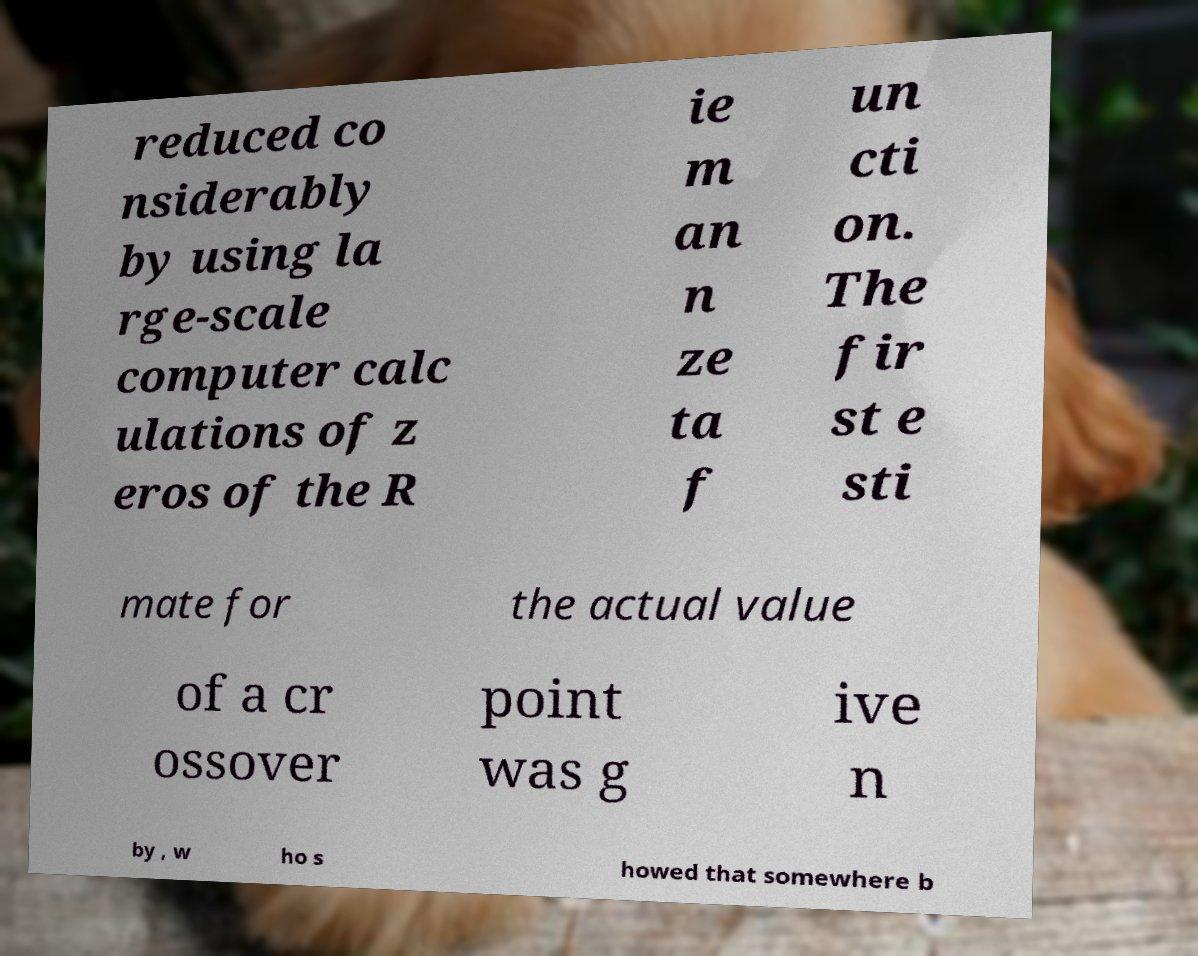Could you assist in decoding the text presented in this image and type it out clearly? reduced co nsiderably by using la rge-scale computer calc ulations of z eros of the R ie m an n ze ta f un cti on. The fir st e sti mate for the actual value of a cr ossover point was g ive n by , w ho s howed that somewhere b 